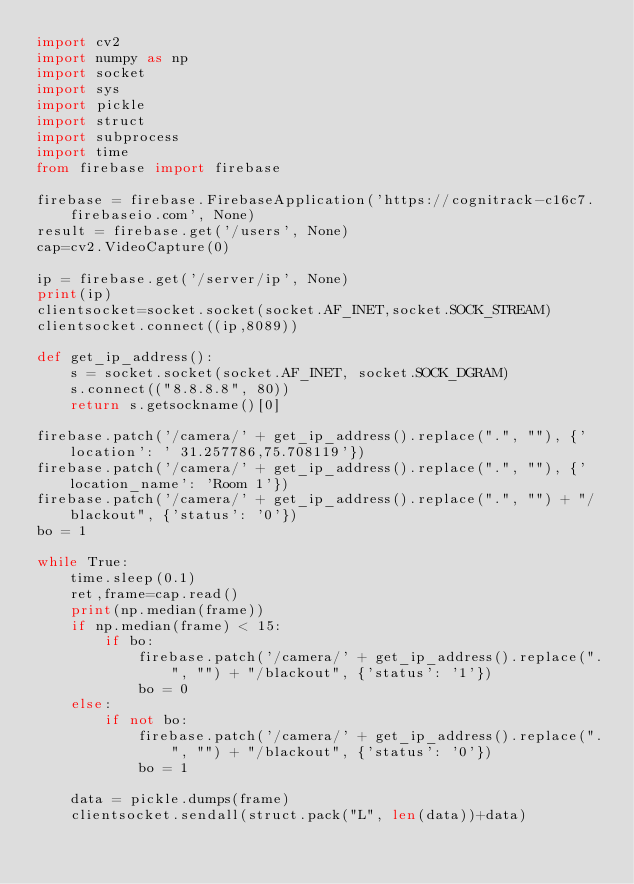<code> <loc_0><loc_0><loc_500><loc_500><_Python_>import cv2
import numpy as np
import socket
import sys
import pickle
import struct
import subprocess
import time
from firebase import firebase

firebase = firebase.FirebaseApplication('https://cognitrack-c16c7.firebaseio.com', None)
result = firebase.get('/users', None)
cap=cv2.VideoCapture(0)

ip = firebase.get('/server/ip', None)
print(ip)
clientsocket=socket.socket(socket.AF_INET,socket.SOCK_STREAM)
clientsocket.connect((ip,8089))

def get_ip_address():
    s = socket.socket(socket.AF_INET, socket.SOCK_DGRAM)
    s.connect(("8.8.8.8", 80))
    return s.getsockname()[0]

firebase.patch('/camera/' + get_ip_address().replace(".", ""), {'location': ' 31.257786,75.708119'})
firebase.patch('/camera/' + get_ip_address().replace(".", ""), {'location_name': 'Room 1'})
firebase.patch('/camera/' + get_ip_address().replace(".", "") + "/blackout", {'status': '0'})
bo = 1

while True:
    time.sleep(0.1)
    ret,frame=cap.read()
    print(np.median(frame))
    if np.median(frame) < 15:
        if bo:
            firebase.patch('/camera/' + get_ip_address().replace(".", "") + "/blackout", {'status': '1'})
            bo = 0
    else:
        if not bo:
            firebase.patch('/camera/' + get_ip_address().replace(".", "") + "/blackout", {'status': '0'})
            bo = 1

    data = pickle.dumps(frame)
    clientsocket.sendall(struct.pack("L", len(data))+data)</code> 